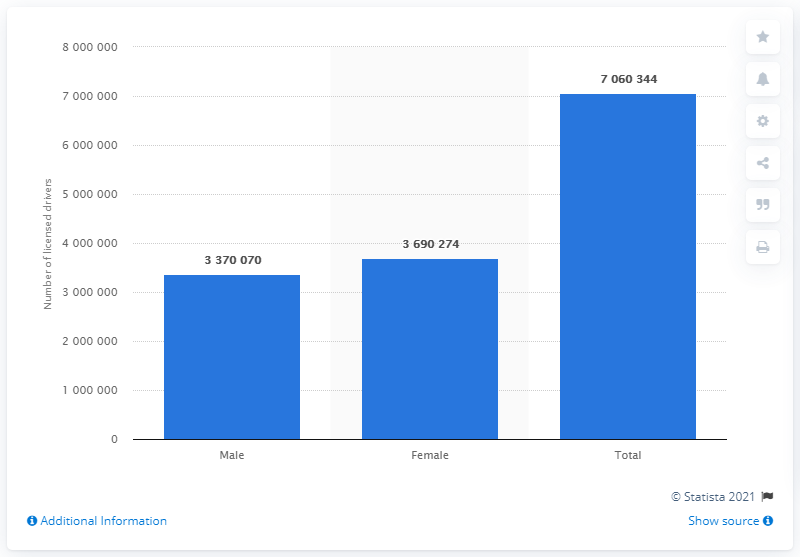Draw attention to some important aspects in this diagram. In 2017, there were approximately 3,690,274 female drivers on the roads in Georgia. 